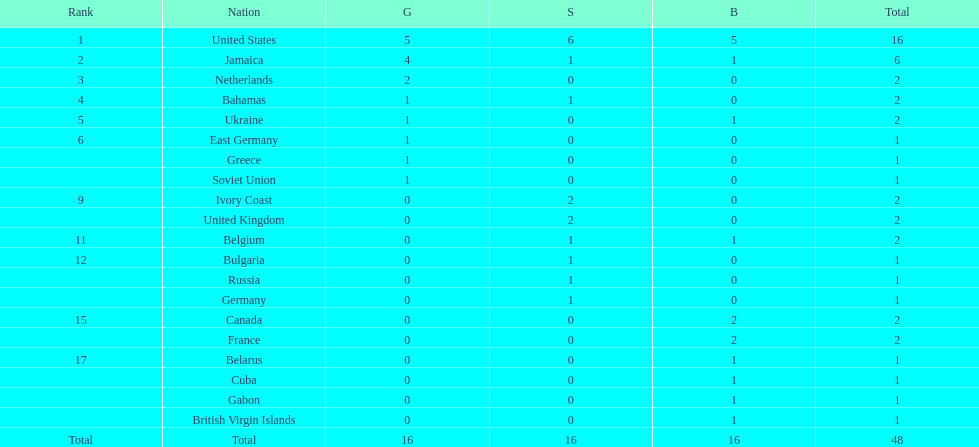How many nations won at least two gold medals? 3. Help me parse the entirety of this table. {'header': ['Rank', 'Nation', 'G', 'S', 'B', 'Total'], 'rows': [['1', 'United States', '5', '6', '5', '16'], ['2', 'Jamaica', '4', '1', '1', '6'], ['3', 'Netherlands', '2', '0', '0', '2'], ['4', 'Bahamas', '1', '1', '0', '2'], ['5', 'Ukraine', '1', '0', '1', '2'], ['6', 'East Germany', '1', '0', '0', '1'], ['', 'Greece', '1', '0', '0', '1'], ['', 'Soviet Union', '1', '0', '0', '1'], ['9', 'Ivory Coast', '0', '2', '0', '2'], ['', 'United Kingdom', '0', '2', '0', '2'], ['11', 'Belgium', '0', '1', '1', '2'], ['12', 'Bulgaria', '0', '1', '0', '1'], ['', 'Russia', '0', '1', '0', '1'], ['', 'Germany', '0', '1', '0', '1'], ['15', 'Canada', '0', '0', '2', '2'], ['', 'France', '0', '0', '2', '2'], ['17', 'Belarus', '0', '0', '1', '1'], ['', 'Cuba', '0', '0', '1', '1'], ['', 'Gabon', '0', '0', '1', '1'], ['', 'British Virgin Islands', '0', '0', '1', '1'], ['Total', 'Total', '16', '16', '16', '48']]} 